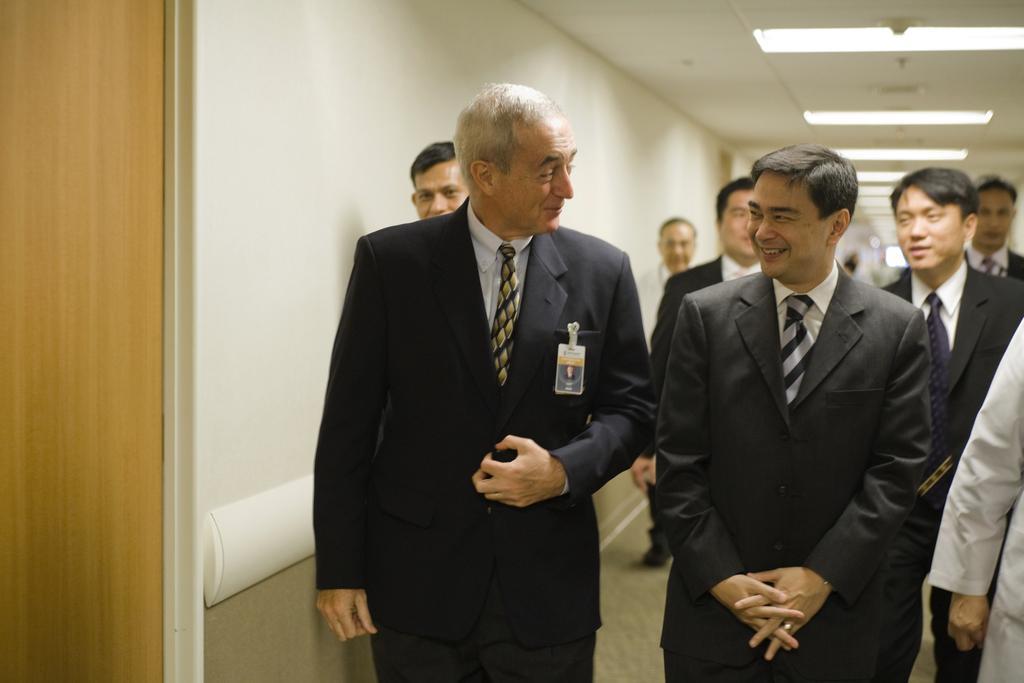Please provide a concise description of this image. In this picture I can see few people are standing and I can see a man wearing ID card and I can see few people wearing ties and coats and I can see few lights on the ceiling and I can see a door on the left side. 